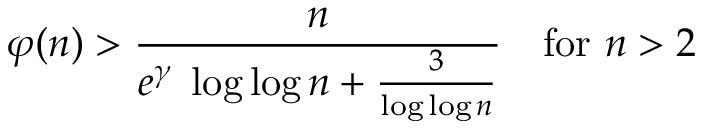Convert formula to latex. <formula><loc_0><loc_0><loc_500><loc_500>\varphi ( n ) > { \frac { n } { e ^ { \gamma } \, \log \log n + { \frac { 3 } { \log \log n } } } } \quad f o r n > 2</formula> 